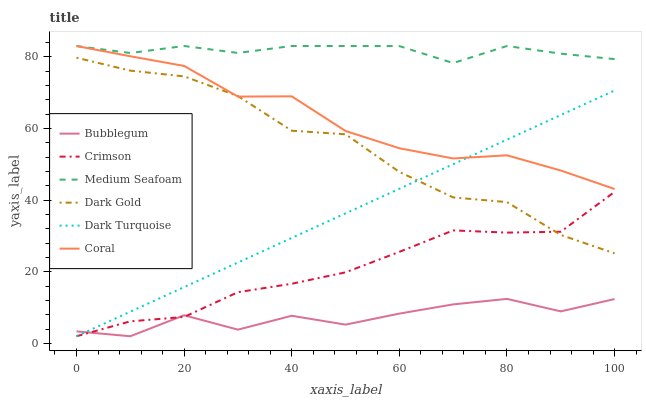Does Dark Turquoise have the minimum area under the curve?
Answer yes or no. No. Does Dark Turquoise have the maximum area under the curve?
Answer yes or no. No. Is Coral the smoothest?
Answer yes or no. No. Is Coral the roughest?
Answer yes or no. No. Does Coral have the lowest value?
Answer yes or no. No. Does Dark Turquoise have the highest value?
Answer yes or no. No. Is Bubblegum less than Medium Seafoam?
Answer yes or no. Yes. Is Dark Gold greater than Bubblegum?
Answer yes or no. Yes. Does Bubblegum intersect Medium Seafoam?
Answer yes or no. No. 